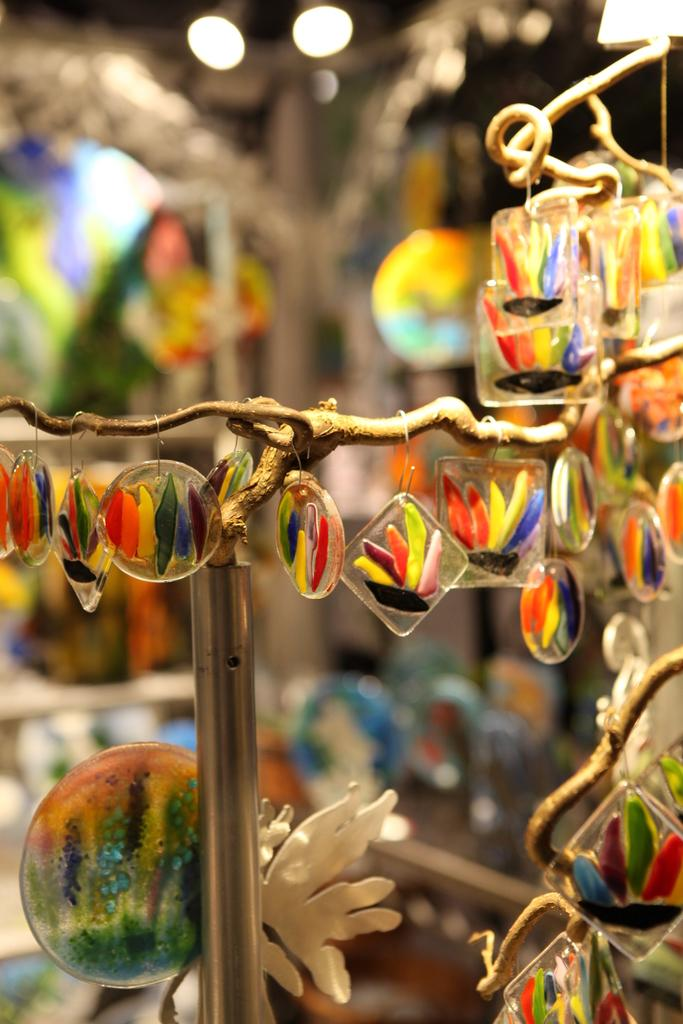What type of objects are in the middle of the image? There are decorative show pieces in the middle of the image. Can you describe the show pieces in more detail? Unfortunately, the facts provided do not give more detail about the show pieces. What might be the purpose of these show pieces? The purpose of the show pieces is likely for decoration or display, but this cannot be confirmed without more information. What type of jelly can be seen on the island in the image? There is no island or jelly present in the image. 